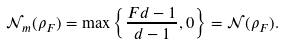<formula> <loc_0><loc_0><loc_500><loc_500>\mathcal { N } _ { m } ( \rho _ { F } ) = \max \left \{ \frac { F d - 1 } { d - 1 } , 0 \right \} = \mathcal { N } ( \rho _ { F } ) .</formula> 